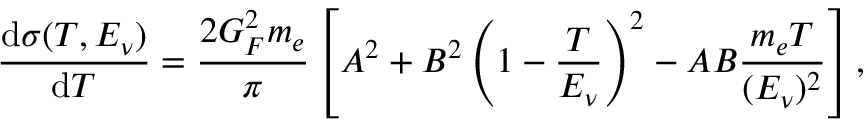Convert formula to latex. <formula><loc_0><loc_0><loc_500><loc_500>\frac { d \sigma ( T , E _ { \nu } ) } { d T } = \frac { 2 G _ { F } ^ { 2 } m _ { e } } { \pi } \left [ A ^ { 2 } + B ^ { 2 } \left ( 1 - \frac { T } { E _ { \nu } } \right ) ^ { 2 } - A B \frac { m _ { e } T } { ( E _ { \nu } ) ^ { 2 } } \right ] ,</formula> 